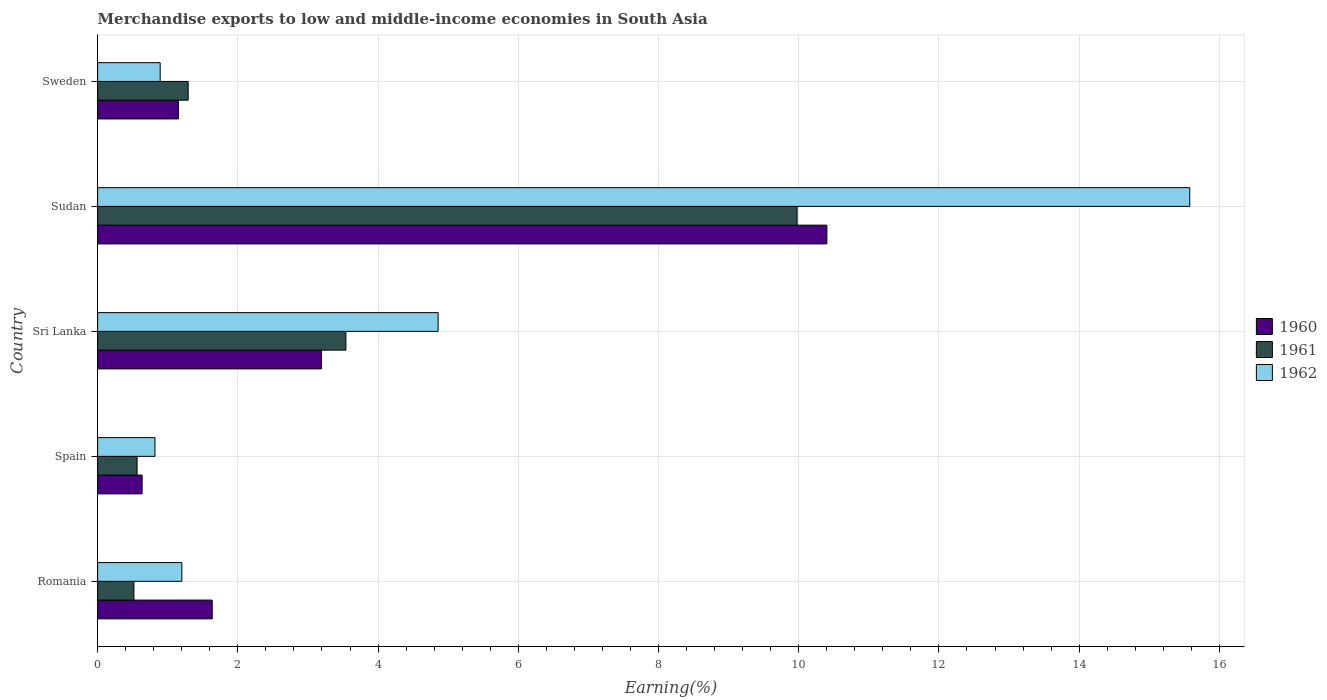How many different coloured bars are there?
Provide a short and direct response. 3. Are the number of bars per tick equal to the number of legend labels?
Your answer should be very brief. Yes. Are the number of bars on each tick of the Y-axis equal?
Ensure brevity in your answer.  Yes. How many bars are there on the 4th tick from the top?
Provide a succinct answer. 3. How many bars are there on the 1st tick from the bottom?
Give a very brief answer. 3. What is the label of the 3rd group of bars from the top?
Offer a very short reply. Sri Lanka. In how many cases, is the number of bars for a given country not equal to the number of legend labels?
Ensure brevity in your answer.  0. What is the percentage of amount earned from merchandise exports in 1962 in Romania?
Make the answer very short. 1.2. Across all countries, what is the maximum percentage of amount earned from merchandise exports in 1961?
Offer a very short reply. 9.98. Across all countries, what is the minimum percentage of amount earned from merchandise exports in 1962?
Your response must be concise. 0.82. In which country was the percentage of amount earned from merchandise exports in 1962 maximum?
Your response must be concise. Sudan. In which country was the percentage of amount earned from merchandise exports in 1961 minimum?
Your response must be concise. Romania. What is the total percentage of amount earned from merchandise exports in 1961 in the graph?
Offer a very short reply. 15.89. What is the difference between the percentage of amount earned from merchandise exports in 1962 in Sri Lanka and that in Sudan?
Provide a short and direct response. -10.72. What is the difference between the percentage of amount earned from merchandise exports in 1962 in Spain and the percentage of amount earned from merchandise exports in 1960 in Sweden?
Keep it short and to the point. -0.33. What is the average percentage of amount earned from merchandise exports in 1961 per country?
Your response must be concise. 3.18. What is the difference between the percentage of amount earned from merchandise exports in 1960 and percentage of amount earned from merchandise exports in 1961 in Sudan?
Provide a short and direct response. 0.42. In how many countries, is the percentage of amount earned from merchandise exports in 1960 greater than 10.8 %?
Keep it short and to the point. 0. What is the ratio of the percentage of amount earned from merchandise exports in 1961 in Romania to that in Sweden?
Offer a terse response. 0.4. Is the percentage of amount earned from merchandise exports in 1962 in Spain less than that in Sudan?
Give a very brief answer. Yes. What is the difference between the highest and the second highest percentage of amount earned from merchandise exports in 1961?
Your response must be concise. 6.44. What is the difference between the highest and the lowest percentage of amount earned from merchandise exports in 1960?
Make the answer very short. 9.77. Is the sum of the percentage of amount earned from merchandise exports in 1962 in Romania and Sweden greater than the maximum percentage of amount earned from merchandise exports in 1960 across all countries?
Provide a short and direct response. No. What does the 2nd bar from the top in Romania represents?
Ensure brevity in your answer.  1961. What does the 3rd bar from the bottom in Romania represents?
Your response must be concise. 1962. Is it the case that in every country, the sum of the percentage of amount earned from merchandise exports in 1961 and percentage of amount earned from merchandise exports in 1962 is greater than the percentage of amount earned from merchandise exports in 1960?
Offer a very short reply. Yes. Are all the bars in the graph horizontal?
Ensure brevity in your answer.  Yes. What is the difference between two consecutive major ticks on the X-axis?
Your answer should be very brief. 2. Does the graph contain any zero values?
Make the answer very short. No. Does the graph contain grids?
Your answer should be compact. Yes. Where does the legend appear in the graph?
Your answer should be compact. Center right. How many legend labels are there?
Your answer should be compact. 3. What is the title of the graph?
Provide a succinct answer. Merchandise exports to low and middle-income economies in South Asia. What is the label or title of the X-axis?
Your answer should be compact. Earning(%). What is the label or title of the Y-axis?
Provide a succinct answer. Country. What is the Earning(%) of 1960 in Romania?
Provide a succinct answer. 1.63. What is the Earning(%) of 1961 in Romania?
Your answer should be very brief. 0.52. What is the Earning(%) of 1962 in Romania?
Ensure brevity in your answer.  1.2. What is the Earning(%) of 1960 in Spain?
Ensure brevity in your answer.  0.63. What is the Earning(%) in 1961 in Spain?
Your answer should be very brief. 0.56. What is the Earning(%) of 1962 in Spain?
Ensure brevity in your answer.  0.82. What is the Earning(%) of 1960 in Sri Lanka?
Keep it short and to the point. 3.19. What is the Earning(%) of 1961 in Sri Lanka?
Keep it short and to the point. 3.54. What is the Earning(%) in 1962 in Sri Lanka?
Offer a very short reply. 4.86. What is the Earning(%) in 1960 in Sudan?
Your answer should be compact. 10.4. What is the Earning(%) in 1961 in Sudan?
Your answer should be compact. 9.98. What is the Earning(%) of 1962 in Sudan?
Provide a short and direct response. 15.58. What is the Earning(%) of 1960 in Sweden?
Keep it short and to the point. 1.15. What is the Earning(%) of 1961 in Sweden?
Your answer should be very brief. 1.29. What is the Earning(%) in 1962 in Sweden?
Your answer should be very brief. 0.89. Across all countries, what is the maximum Earning(%) of 1960?
Your answer should be compact. 10.4. Across all countries, what is the maximum Earning(%) in 1961?
Offer a terse response. 9.98. Across all countries, what is the maximum Earning(%) in 1962?
Your response must be concise. 15.58. Across all countries, what is the minimum Earning(%) of 1960?
Offer a very short reply. 0.63. Across all countries, what is the minimum Earning(%) of 1961?
Give a very brief answer. 0.52. Across all countries, what is the minimum Earning(%) in 1962?
Keep it short and to the point. 0.82. What is the total Earning(%) in 1960 in the graph?
Provide a short and direct response. 17.02. What is the total Earning(%) in 1961 in the graph?
Ensure brevity in your answer.  15.89. What is the total Earning(%) in 1962 in the graph?
Provide a short and direct response. 23.35. What is the difference between the Earning(%) in 1961 in Romania and that in Spain?
Your response must be concise. -0.05. What is the difference between the Earning(%) in 1962 in Romania and that in Spain?
Your answer should be very brief. 0.38. What is the difference between the Earning(%) of 1960 in Romania and that in Sri Lanka?
Your answer should be compact. -1.56. What is the difference between the Earning(%) in 1961 in Romania and that in Sri Lanka?
Your response must be concise. -3.02. What is the difference between the Earning(%) in 1962 in Romania and that in Sri Lanka?
Offer a terse response. -3.66. What is the difference between the Earning(%) of 1960 in Romania and that in Sudan?
Your answer should be compact. -8.77. What is the difference between the Earning(%) of 1961 in Romania and that in Sudan?
Make the answer very short. -9.46. What is the difference between the Earning(%) of 1962 in Romania and that in Sudan?
Offer a very short reply. -14.38. What is the difference between the Earning(%) of 1960 in Romania and that in Sweden?
Offer a terse response. 0.48. What is the difference between the Earning(%) of 1961 in Romania and that in Sweden?
Keep it short and to the point. -0.77. What is the difference between the Earning(%) of 1962 in Romania and that in Sweden?
Make the answer very short. 0.31. What is the difference between the Earning(%) in 1960 in Spain and that in Sri Lanka?
Your response must be concise. -2.56. What is the difference between the Earning(%) in 1961 in Spain and that in Sri Lanka?
Your answer should be very brief. -2.98. What is the difference between the Earning(%) in 1962 in Spain and that in Sri Lanka?
Provide a succinct answer. -4.04. What is the difference between the Earning(%) of 1960 in Spain and that in Sudan?
Offer a very short reply. -9.77. What is the difference between the Earning(%) of 1961 in Spain and that in Sudan?
Offer a very short reply. -9.41. What is the difference between the Earning(%) in 1962 in Spain and that in Sudan?
Provide a succinct answer. -14.76. What is the difference between the Earning(%) in 1960 in Spain and that in Sweden?
Give a very brief answer. -0.52. What is the difference between the Earning(%) in 1961 in Spain and that in Sweden?
Make the answer very short. -0.73. What is the difference between the Earning(%) of 1962 in Spain and that in Sweden?
Make the answer very short. -0.07. What is the difference between the Earning(%) of 1960 in Sri Lanka and that in Sudan?
Provide a short and direct response. -7.21. What is the difference between the Earning(%) in 1961 in Sri Lanka and that in Sudan?
Provide a short and direct response. -6.44. What is the difference between the Earning(%) in 1962 in Sri Lanka and that in Sudan?
Offer a very short reply. -10.72. What is the difference between the Earning(%) of 1960 in Sri Lanka and that in Sweden?
Your answer should be very brief. 2.04. What is the difference between the Earning(%) in 1961 in Sri Lanka and that in Sweden?
Provide a succinct answer. 2.25. What is the difference between the Earning(%) of 1962 in Sri Lanka and that in Sweden?
Provide a succinct answer. 3.97. What is the difference between the Earning(%) in 1960 in Sudan and that in Sweden?
Provide a succinct answer. 9.25. What is the difference between the Earning(%) of 1961 in Sudan and that in Sweden?
Give a very brief answer. 8.69. What is the difference between the Earning(%) of 1962 in Sudan and that in Sweden?
Provide a succinct answer. 14.69. What is the difference between the Earning(%) in 1960 in Romania and the Earning(%) in 1961 in Spain?
Offer a terse response. 1.07. What is the difference between the Earning(%) of 1960 in Romania and the Earning(%) of 1962 in Spain?
Your response must be concise. 0.82. What is the difference between the Earning(%) in 1961 in Romania and the Earning(%) in 1962 in Spain?
Keep it short and to the point. -0.3. What is the difference between the Earning(%) in 1960 in Romania and the Earning(%) in 1961 in Sri Lanka?
Provide a short and direct response. -1.91. What is the difference between the Earning(%) of 1960 in Romania and the Earning(%) of 1962 in Sri Lanka?
Offer a very short reply. -3.22. What is the difference between the Earning(%) in 1961 in Romania and the Earning(%) in 1962 in Sri Lanka?
Provide a succinct answer. -4.34. What is the difference between the Earning(%) of 1960 in Romania and the Earning(%) of 1961 in Sudan?
Your answer should be very brief. -8.34. What is the difference between the Earning(%) in 1960 in Romania and the Earning(%) in 1962 in Sudan?
Provide a short and direct response. -13.94. What is the difference between the Earning(%) in 1961 in Romania and the Earning(%) in 1962 in Sudan?
Offer a very short reply. -15.06. What is the difference between the Earning(%) of 1960 in Romania and the Earning(%) of 1961 in Sweden?
Offer a very short reply. 0.34. What is the difference between the Earning(%) in 1960 in Romania and the Earning(%) in 1962 in Sweden?
Your answer should be compact. 0.74. What is the difference between the Earning(%) of 1961 in Romania and the Earning(%) of 1962 in Sweden?
Provide a succinct answer. -0.37. What is the difference between the Earning(%) in 1960 in Spain and the Earning(%) in 1961 in Sri Lanka?
Your response must be concise. -2.91. What is the difference between the Earning(%) in 1960 in Spain and the Earning(%) in 1962 in Sri Lanka?
Keep it short and to the point. -4.22. What is the difference between the Earning(%) in 1961 in Spain and the Earning(%) in 1962 in Sri Lanka?
Keep it short and to the point. -4.29. What is the difference between the Earning(%) in 1960 in Spain and the Earning(%) in 1961 in Sudan?
Your response must be concise. -9.34. What is the difference between the Earning(%) in 1960 in Spain and the Earning(%) in 1962 in Sudan?
Ensure brevity in your answer.  -14.94. What is the difference between the Earning(%) of 1961 in Spain and the Earning(%) of 1962 in Sudan?
Offer a very short reply. -15.02. What is the difference between the Earning(%) in 1960 in Spain and the Earning(%) in 1961 in Sweden?
Your answer should be very brief. -0.66. What is the difference between the Earning(%) in 1960 in Spain and the Earning(%) in 1962 in Sweden?
Give a very brief answer. -0.26. What is the difference between the Earning(%) in 1961 in Spain and the Earning(%) in 1962 in Sweden?
Offer a very short reply. -0.33. What is the difference between the Earning(%) in 1960 in Sri Lanka and the Earning(%) in 1961 in Sudan?
Offer a terse response. -6.78. What is the difference between the Earning(%) of 1960 in Sri Lanka and the Earning(%) of 1962 in Sudan?
Provide a short and direct response. -12.38. What is the difference between the Earning(%) of 1961 in Sri Lanka and the Earning(%) of 1962 in Sudan?
Make the answer very short. -12.04. What is the difference between the Earning(%) of 1960 in Sri Lanka and the Earning(%) of 1961 in Sweden?
Your answer should be very brief. 1.9. What is the difference between the Earning(%) in 1960 in Sri Lanka and the Earning(%) in 1962 in Sweden?
Ensure brevity in your answer.  2.3. What is the difference between the Earning(%) of 1961 in Sri Lanka and the Earning(%) of 1962 in Sweden?
Give a very brief answer. 2.65. What is the difference between the Earning(%) in 1960 in Sudan and the Earning(%) in 1961 in Sweden?
Ensure brevity in your answer.  9.11. What is the difference between the Earning(%) of 1960 in Sudan and the Earning(%) of 1962 in Sweden?
Make the answer very short. 9.51. What is the difference between the Earning(%) in 1961 in Sudan and the Earning(%) in 1962 in Sweden?
Offer a terse response. 9.09. What is the average Earning(%) in 1960 per country?
Offer a very short reply. 3.4. What is the average Earning(%) in 1961 per country?
Give a very brief answer. 3.18. What is the average Earning(%) of 1962 per country?
Give a very brief answer. 4.67. What is the difference between the Earning(%) of 1960 and Earning(%) of 1961 in Romania?
Make the answer very short. 1.12. What is the difference between the Earning(%) of 1960 and Earning(%) of 1962 in Romania?
Offer a terse response. 0.43. What is the difference between the Earning(%) in 1961 and Earning(%) in 1962 in Romania?
Keep it short and to the point. -0.68. What is the difference between the Earning(%) of 1960 and Earning(%) of 1961 in Spain?
Offer a terse response. 0.07. What is the difference between the Earning(%) of 1960 and Earning(%) of 1962 in Spain?
Your answer should be very brief. -0.18. What is the difference between the Earning(%) of 1961 and Earning(%) of 1962 in Spain?
Your answer should be compact. -0.25. What is the difference between the Earning(%) of 1960 and Earning(%) of 1961 in Sri Lanka?
Offer a terse response. -0.35. What is the difference between the Earning(%) in 1960 and Earning(%) in 1962 in Sri Lanka?
Offer a terse response. -1.66. What is the difference between the Earning(%) of 1961 and Earning(%) of 1962 in Sri Lanka?
Offer a very short reply. -1.32. What is the difference between the Earning(%) in 1960 and Earning(%) in 1961 in Sudan?
Your answer should be very brief. 0.42. What is the difference between the Earning(%) in 1960 and Earning(%) in 1962 in Sudan?
Offer a terse response. -5.18. What is the difference between the Earning(%) of 1961 and Earning(%) of 1962 in Sudan?
Make the answer very short. -5.6. What is the difference between the Earning(%) in 1960 and Earning(%) in 1961 in Sweden?
Keep it short and to the point. -0.14. What is the difference between the Earning(%) in 1960 and Earning(%) in 1962 in Sweden?
Your response must be concise. 0.26. What is the difference between the Earning(%) in 1961 and Earning(%) in 1962 in Sweden?
Provide a short and direct response. 0.4. What is the ratio of the Earning(%) of 1960 in Romania to that in Spain?
Your response must be concise. 2.58. What is the ratio of the Earning(%) in 1961 in Romania to that in Spain?
Provide a short and direct response. 0.92. What is the ratio of the Earning(%) in 1962 in Romania to that in Spain?
Your answer should be very brief. 1.47. What is the ratio of the Earning(%) of 1960 in Romania to that in Sri Lanka?
Your answer should be compact. 0.51. What is the ratio of the Earning(%) of 1961 in Romania to that in Sri Lanka?
Keep it short and to the point. 0.15. What is the ratio of the Earning(%) of 1962 in Romania to that in Sri Lanka?
Provide a short and direct response. 0.25. What is the ratio of the Earning(%) in 1960 in Romania to that in Sudan?
Make the answer very short. 0.16. What is the ratio of the Earning(%) in 1961 in Romania to that in Sudan?
Your answer should be compact. 0.05. What is the ratio of the Earning(%) of 1962 in Romania to that in Sudan?
Provide a short and direct response. 0.08. What is the ratio of the Earning(%) in 1960 in Romania to that in Sweden?
Make the answer very short. 1.42. What is the ratio of the Earning(%) of 1961 in Romania to that in Sweden?
Offer a terse response. 0.4. What is the ratio of the Earning(%) of 1962 in Romania to that in Sweden?
Make the answer very short. 1.35. What is the ratio of the Earning(%) in 1960 in Spain to that in Sri Lanka?
Provide a short and direct response. 0.2. What is the ratio of the Earning(%) of 1961 in Spain to that in Sri Lanka?
Ensure brevity in your answer.  0.16. What is the ratio of the Earning(%) of 1962 in Spain to that in Sri Lanka?
Your response must be concise. 0.17. What is the ratio of the Earning(%) in 1960 in Spain to that in Sudan?
Your response must be concise. 0.06. What is the ratio of the Earning(%) in 1961 in Spain to that in Sudan?
Offer a terse response. 0.06. What is the ratio of the Earning(%) in 1962 in Spain to that in Sudan?
Your answer should be very brief. 0.05. What is the ratio of the Earning(%) of 1960 in Spain to that in Sweden?
Give a very brief answer. 0.55. What is the ratio of the Earning(%) of 1961 in Spain to that in Sweden?
Provide a succinct answer. 0.44. What is the ratio of the Earning(%) in 1962 in Spain to that in Sweden?
Offer a terse response. 0.92. What is the ratio of the Earning(%) in 1960 in Sri Lanka to that in Sudan?
Your answer should be very brief. 0.31. What is the ratio of the Earning(%) in 1961 in Sri Lanka to that in Sudan?
Offer a very short reply. 0.35. What is the ratio of the Earning(%) in 1962 in Sri Lanka to that in Sudan?
Offer a very short reply. 0.31. What is the ratio of the Earning(%) in 1960 in Sri Lanka to that in Sweden?
Give a very brief answer. 2.77. What is the ratio of the Earning(%) in 1961 in Sri Lanka to that in Sweden?
Your answer should be compact. 2.74. What is the ratio of the Earning(%) of 1962 in Sri Lanka to that in Sweden?
Keep it short and to the point. 5.45. What is the ratio of the Earning(%) of 1960 in Sudan to that in Sweden?
Make the answer very short. 9.03. What is the ratio of the Earning(%) in 1961 in Sudan to that in Sweden?
Give a very brief answer. 7.73. What is the ratio of the Earning(%) of 1962 in Sudan to that in Sweden?
Your response must be concise. 17.47. What is the difference between the highest and the second highest Earning(%) in 1960?
Provide a succinct answer. 7.21. What is the difference between the highest and the second highest Earning(%) of 1961?
Provide a short and direct response. 6.44. What is the difference between the highest and the second highest Earning(%) of 1962?
Your response must be concise. 10.72. What is the difference between the highest and the lowest Earning(%) of 1960?
Your response must be concise. 9.77. What is the difference between the highest and the lowest Earning(%) of 1961?
Your answer should be very brief. 9.46. What is the difference between the highest and the lowest Earning(%) in 1962?
Your response must be concise. 14.76. 